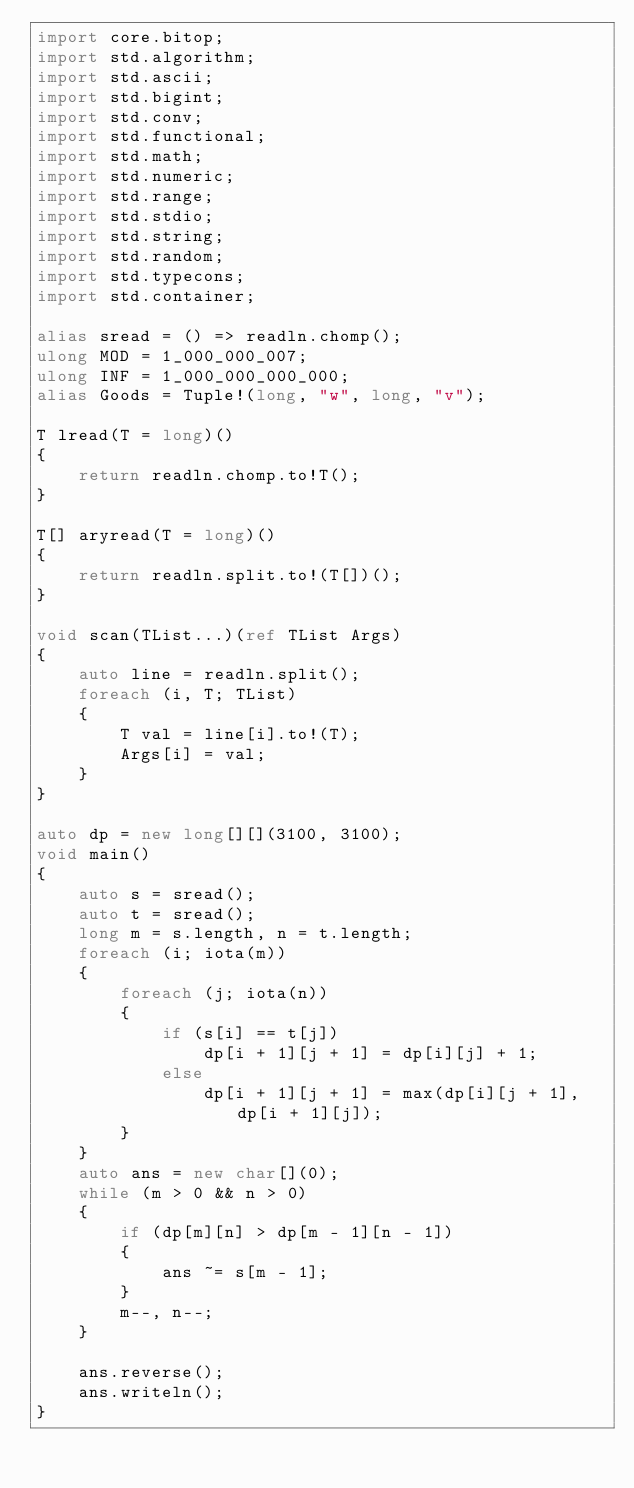Convert code to text. <code><loc_0><loc_0><loc_500><loc_500><_D_>import core.bitop;
import std.algorithm;
import std.ascii;
import std.bigint;
import std.conv;
import std.functional;
import std.math;
import std.numeric;
import std.range;
import std.stdio;
import std.string;
import std.random;
import std.typecons;
import std.container;

alias sread = () => readln.chomp();
ulong MOD = 1_000_000_007;
ulong INF = 1_000_000_000_000;
alias Goods = Tuple!(long, "w", long, "v");

T lread(T = long)()
{
    return readln.chomp.to!T();
}

T[] aryread(T = long)()
{
    return readln.split.to!(T[])();
}

void scan(TList...)(ref TList Args)
{
    auto line = readln.split();
    foreach (i, T; TList)
    {
        T val = line[i].to!(T);
        Args[i] = val;
    }
}

auto dp = new long[][](3100, 3100);
void main()
{
    auto s = sread();
    auto t = sread();
    long m = s.length, n = t.length;
    foreach (i; iota(m))
    {
        foreach (j; iota(n))
        {
            if (s[i] == t[j])
                dp[i + 1][j + 1] = dp[i][j] + 1;
            else
                dp[i + 1][j + 1] = max(dp[i][j + 1], dp[i + 1][j]);
        }
    }
    auto ans = new char[](0);
    while (m > 0 && n > 0)
    {
        if (dp[m][n] > dp[m - 1][n - 1])
        {
            ans ~= s[m - 1];
        }
        m--, n--;
    }

    ans.reverse();
    ans.writeln();
}
</code> 